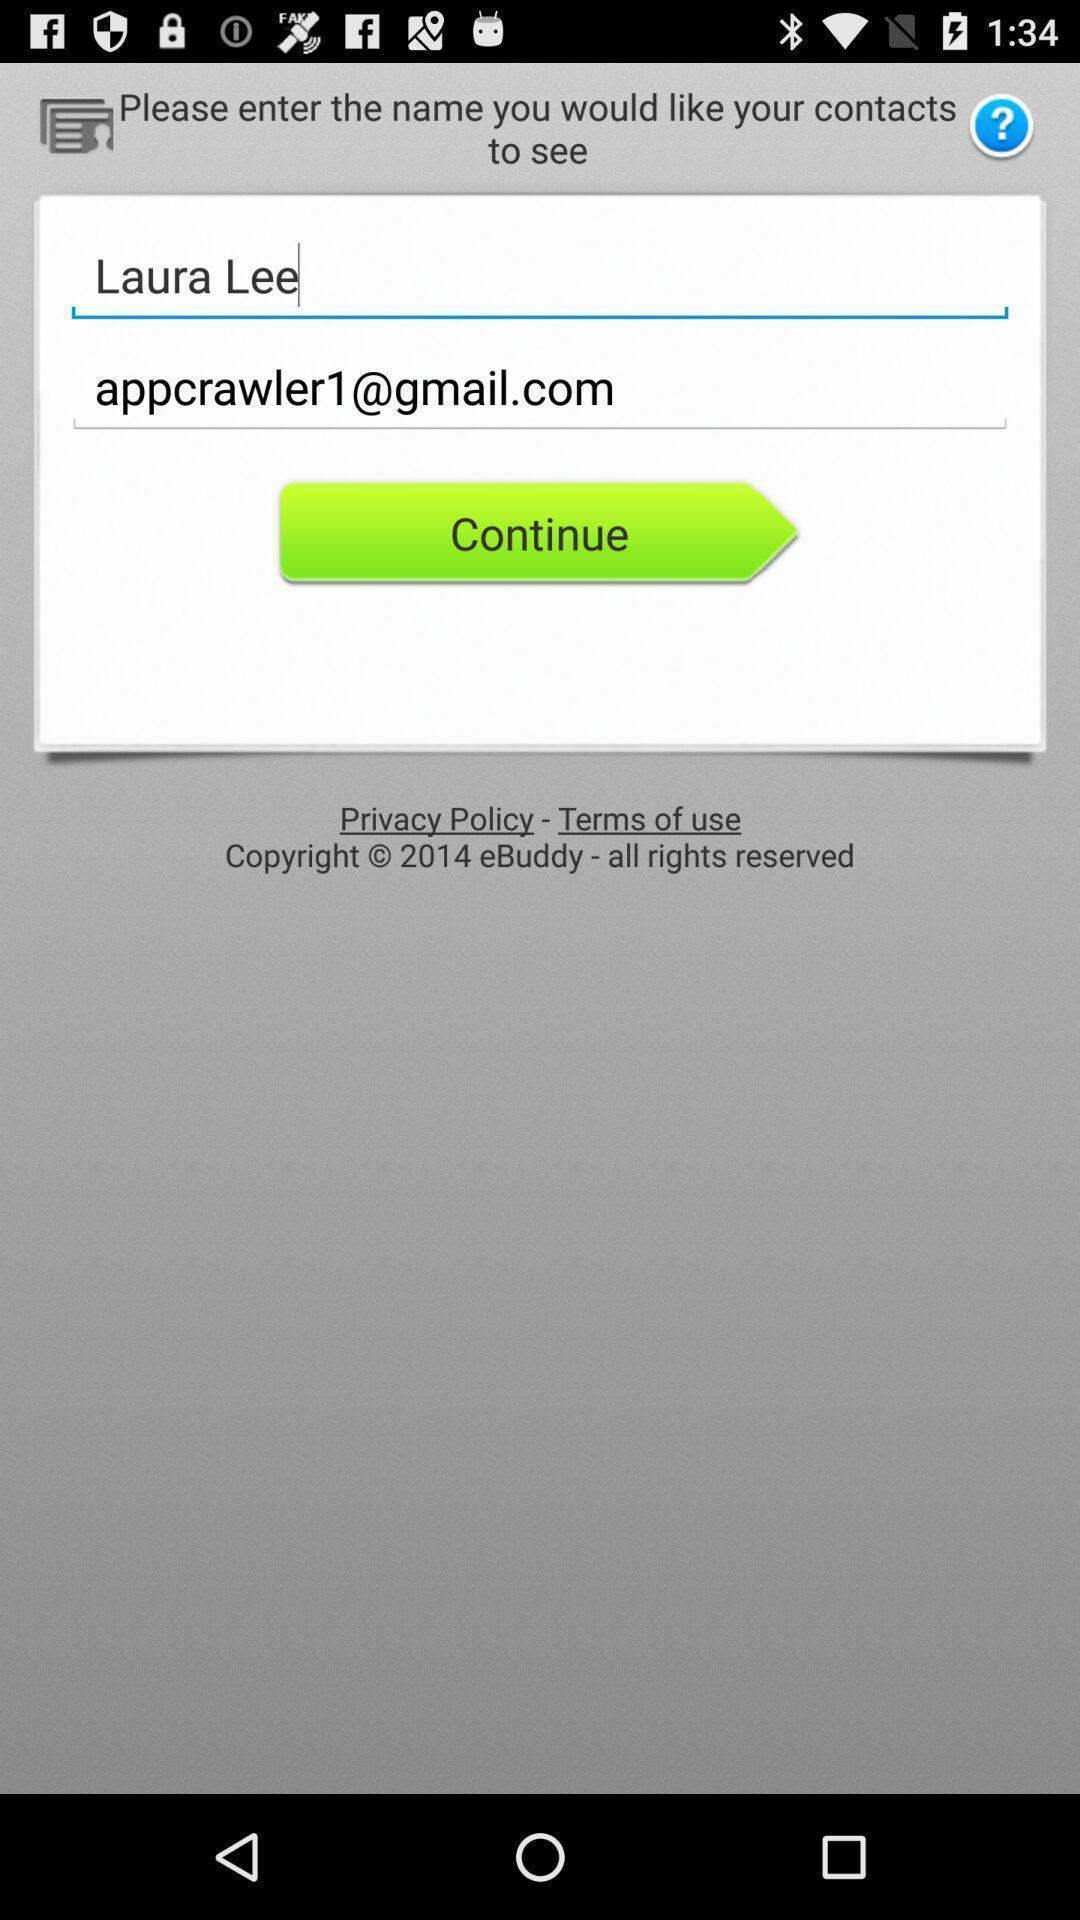Give me a summary of this screen capture. Pop up showing email address. 